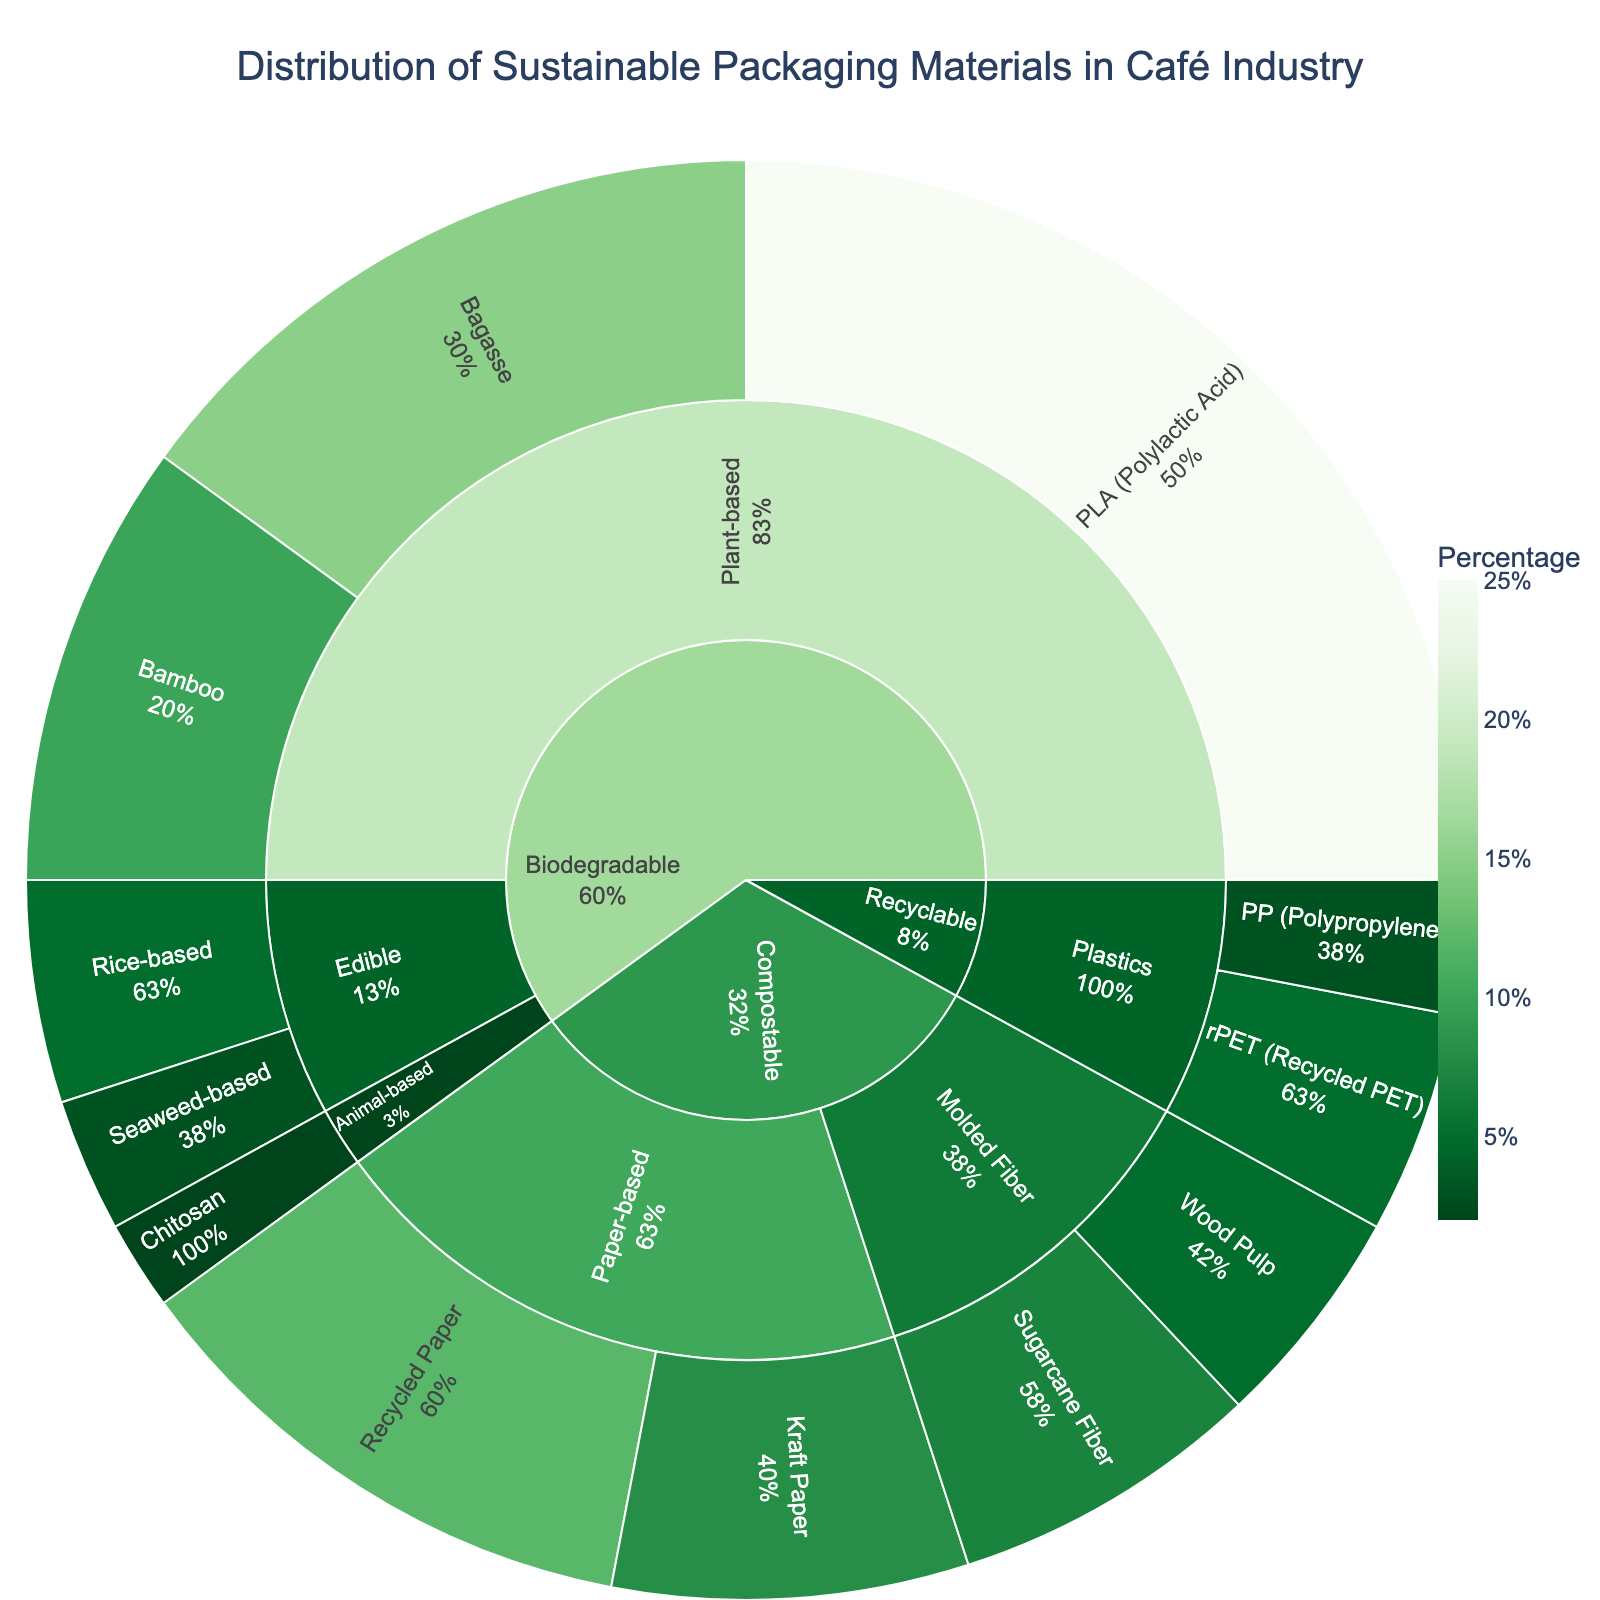What is the title of the sunburst plot? Look at the top of the figure where the title is displayed, which usually provides a summary of the entire chart. The title indicates the main subject of the visualized data.
Answer: Distribution of Sustainable Packaging Materials in Café Industry Which subcategory under Biodegradable has the highest percentage? Examine the Biodegradable section first, then look at its subcategories and their corresponding percentages. Sum the percentages and identify the highest value.
Answer: Plant-based What is the combined percentage of all Edible materials under Biodegradable? Add the percentages of Rice-based and Seaweed-based materials within the Biodegradable category to find the total for Edible materials.
Answer: 8 How does the percentage of Recycled Paper under Compostable compare to that of rPET (Recycled PET) under Recyclable? Identify the percentages of Recycled Paper and rPET from their respective categories. Compare these two values directly.
Answer: Recycled Paper (12%) is greater than rPET (5%) What is the smallest segment in the sunburst plot and what material does it represent? Locate the segment with the smallest percentage value within the entire plot. This can usually be found visually as the smallest segment.
Answer: Chitosan (2%) What percentage of the total are Plant-based biodegradable materials contributing? Sum the percentages of all Plant-based materials (PLA, Bagasse, Bamboo) which are all under the Biodegradable category. Add these values together.
Answer: 50 How does the percentage of Kraft Paper compare with that of the combined Molded Fiber subcategory under Compostable? First, find the percentage for Kraft Paper. Then, sum the percentages of the Sugarcane Fiber and Wood Pulp, and compare the two results.
Answer: Kraft Paper (8%) is less than combined Molded Fiber (12%) What are the main categories of packaging materials displayed in the plot? Look at the outermost layer of the sunburst plot which typically shows the main categories. Identify these distinct large sections.
Answer: Biodegradable, Compostable, Recyclable What is the total percentage of all Plastic materials used in the café industry according to the plot? Add the percentages of all Plastic materials (rPET and PP) under the Recyclable category.
Answer: 8 How many different subcategories exist within the Biodegradable category, and what are they? Under the Biodegradable category, identify and count each unique subcategory based on their labels.
Answer: 3 subcategories (Plant-based, Edible, Animal-based) 